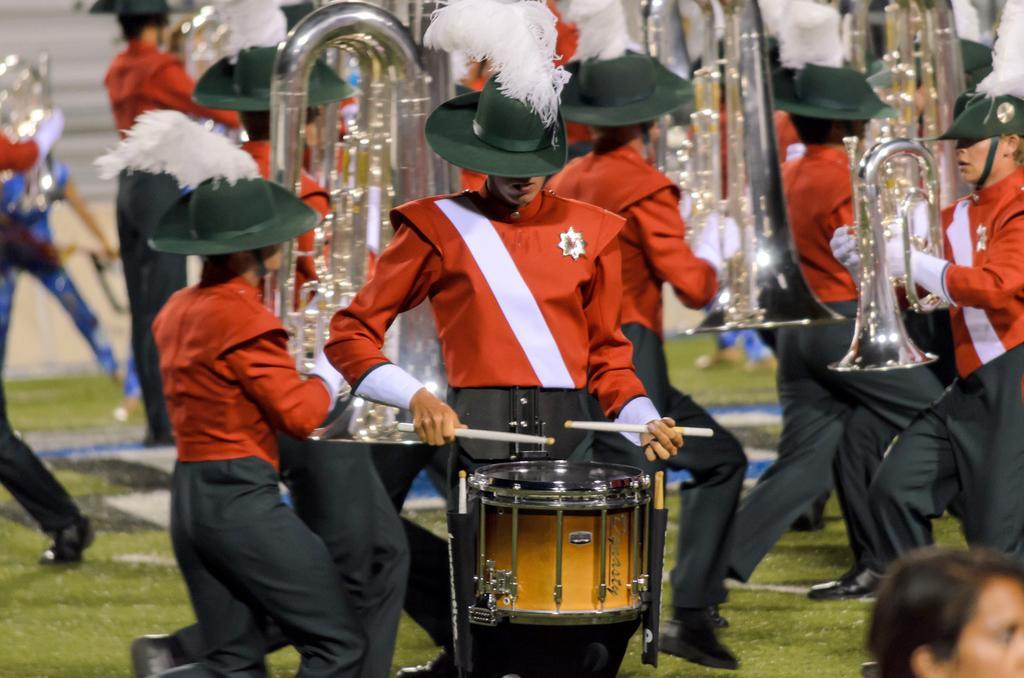Please provide a concise description of this image. In this picture we can see some persons playing musical instruments. And this is grass. 